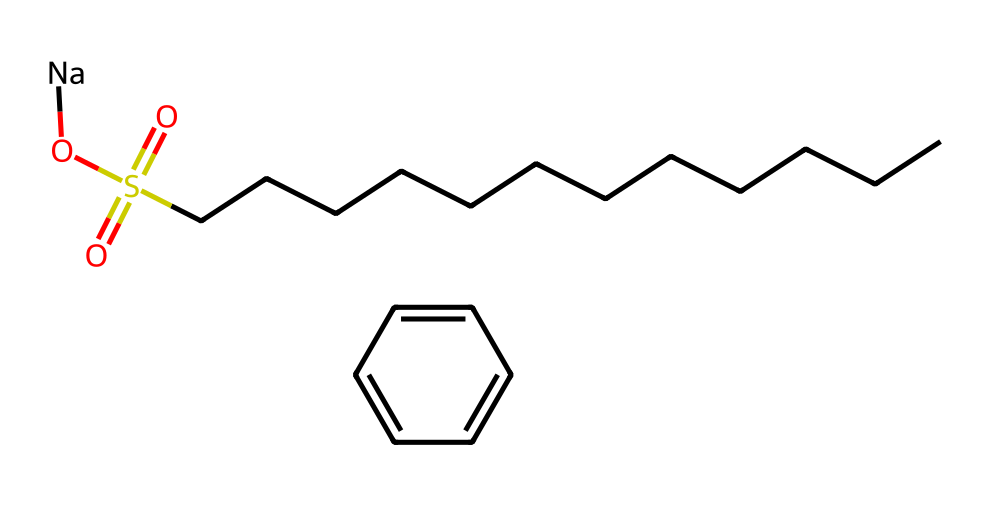What is the main functional group in this chemical? The functional group visible in the chemical is a sulfonate group, indicated by "S(=O)(=O)O" in the SMILES representation. Functional groups typically determine the chemical's reactivity and properties.
Answer: sulfonate How many carbon atoms are present in this alkyl chain? The "CCCCCCCCCCCC" segment in the SMILES indicates a continuous chain of 12 carbon atoms. Counting these gives us the total number of carbon atoms in the alkyl chain.
Answer: 12 Which metal ion is associated with this surfactant? The "Na" at the end of the SMILES indicates the presence of sodium as a metal ion. Surfactants often exist as salts, and sodium is a common counterion for sulfonate groups.
Answer: sodium What type of surfactant is represented by this chemical structure? Given that the molecule has a long hydrophobic carbon chain and a sulfonate group, it classifies as an anionic surfactant. Anionic surfactants are characterized by a negatively charged head group and are commonly used in detergents.
Answer: anionic What is the role of the benzene ring in this molecule? The benzene ring "c1ccccc1" contributes to the molecule's hydrophobic characteristics and enhances adsorption onto surfaces. Aromatic rings in surfactants typically increase their effectiveness in reducing surface tension by providing stability.
Answer: hydrophobic How many oxygen atoms are found in the sulfonate group? The sulfonate group "S(=O)(=O)O" contains three oxygen atoms. The double bonds (indicated by ="") correspond to two oxygen atoms, and the single-bonded oxygen accounts for another one.
Answer: 3 What is the nature of the charge on this surfactant? This surfactant has a negative charge due to the sulfonate group, which dissociates in solution, allowing it to interact with various surfaces and enhance cleaning.
Answer: negative 